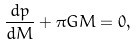<formula> <loc_0><loc_0><loc_500><loc_500>\frac { d p } { d M } + \pi G M = 0 ,</formula> 